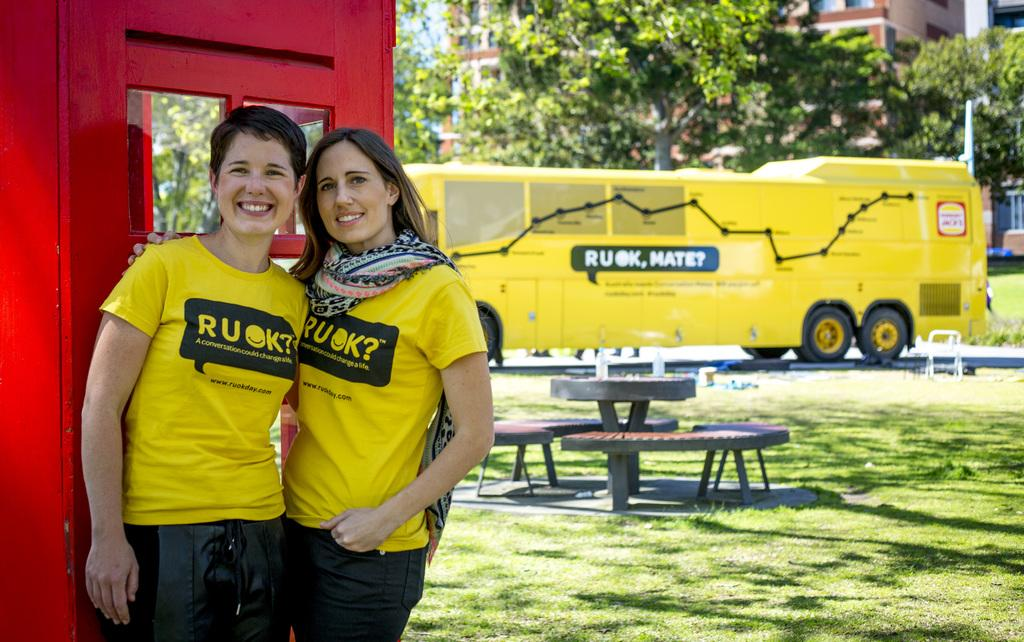How many women are in the image? There are two women in the image. What are the women wearing? Both women are wearing yellow T-shirts. What is the facial expression of the women? The women are smiling. What can be seen in the background of the image? There is a booth, a bus, trees, a building, a table, and chairs in the background of the image. What type of bun is being served on the table in the image? There is no bun present in the image; the table is in the background, but no food items are visible. How many matches are visible on the table in the image? There are no matches present in the image; the table is in the background, but no matchsticks or similar items are visible. 